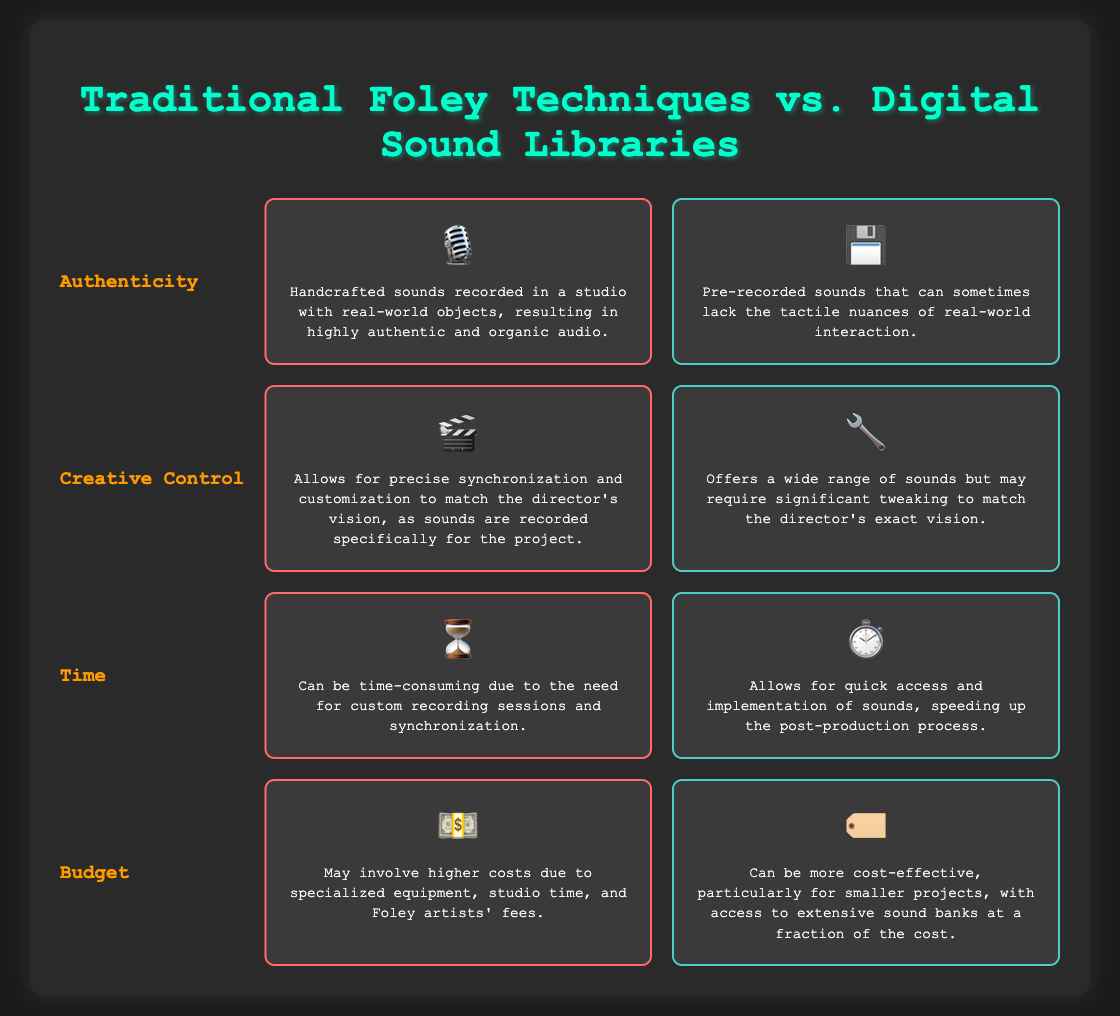What icon represents Traditional Foley Techniques? The icon representing Traditional Foley Techniques in the document is a microphone (🎙️), indicating the use of handcrafted sound recording.
Answer: 🎙️ What is a key advantage of Digital Sound Libraries in terms of time? The document states that Digital Sound Libraries allow for quick access and implementation of sounds, speeding up the post-production process.
Answer: Quick access What color border is used for the Traditional Foley Techniques section? The document specifies that Traditional Foley Techniques has a border color of red (#ff6b6b), indicating its differentiated category.
Answer: Red Which category emphasizes the ability for precise synchronization with the director's vision? The aspect that highlights this ability is "Creative Control" associated with Traditional Foley Techniques, as the sounds are recorded specifically for the project.
Answer: Creative Control What is a potential drawback of using Digital Sound Libraries for authenticity? According to the document, a potential drawback is that pre-recorded sounds can sometimes lack the tactile nuances of real-world interaction.
Answer: Lack of tactile nuances How does the budget requirement for Traditional Foley Techniques compare to Digital Sound Libraries? The document indicates that Traditional Foley Techniques may involve higher costs due to specialized equipment, while Digital Sound Libraries are generally more cost-effective.
Answer: Higher costs 